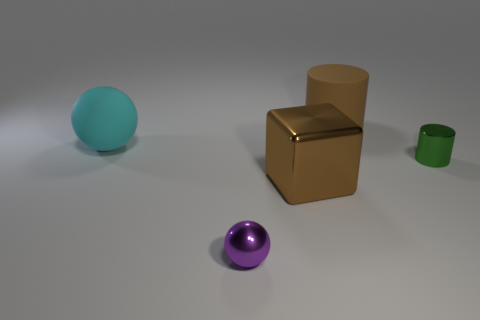Does the big ball have the same color as the block?
Ensure brevity in your answer.  No. The object that is both on the right side of the brown metallic thing and in front of the large sphere is made of what material?
Ensure brevity in your answer.  Metal. The matte cylinder has what size?
Make the answer very short. Large. There is a big matte object right of the sphere in front of the brown block; how many large brown objects are in front of it?
Give a very brief answer. 1. What is the shape of the shiny thing that is on the right side of the metal cube that is in front of the green object?
Offer a very short reply. Cylinder. The cyan object that is the same shape as the small purple shiny thing is what size?
Make the answer very short. Large. Are there any other things that are the same size as the brown rubber thing?
Provide a succinct answer. Yes. The cylinder behind the green metallic cylinder is what color?
Make the answer very short. Brown. What material is the cylinder that is to the right of the large brown thing that is behind the small thing behind the large shiny thing?
Provide a short and direct response. Metal. What size is the ball that is in front of the tiny thing behind the metal sphere?
Offer a terse response. Small. 